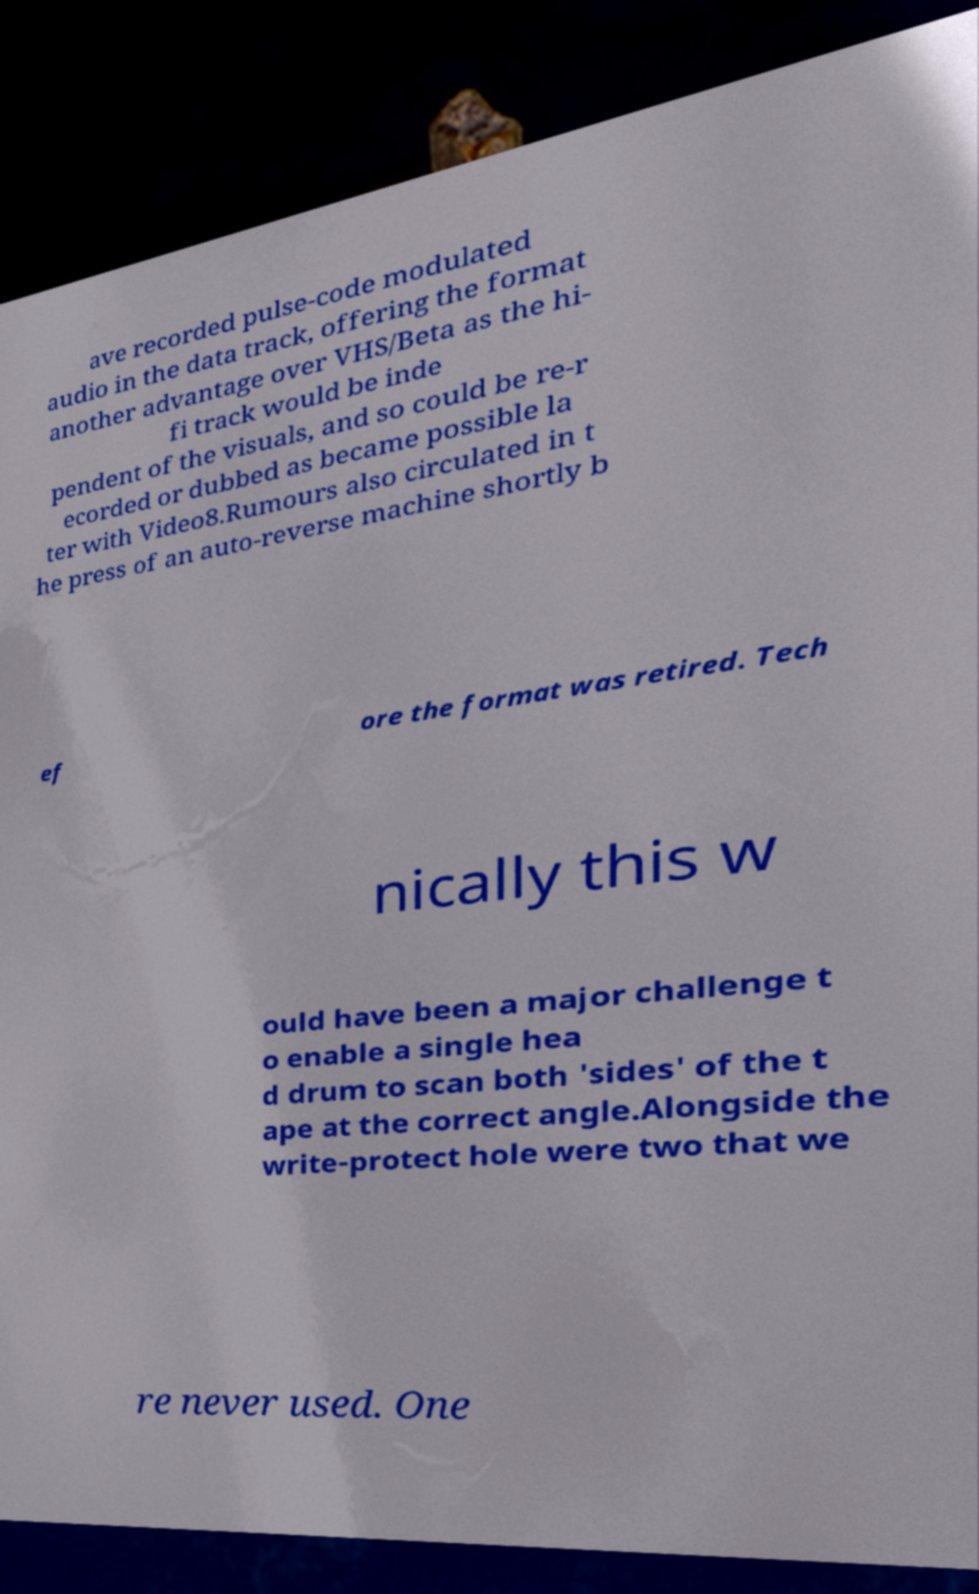Can you accurately transcribe the text from the provided image for me? ave recorded pulse-code modulated audio in the data track, offering the format another advantage over VHS/Beta as the hi- fi track would be inde pendent of the visuals, and so could be re-r ecorded or dubbed as became possible la ter with Video8.Rumours also circulated in t he press of an auto-reverse machine shortly b ef ore the format was retired. Tech nically this w ould have been a major challenge t o enable a single hea d drum to scan both 'sides' of the t ape at the correct angle.Alongside the write-protect hole were two that we re never used. One 